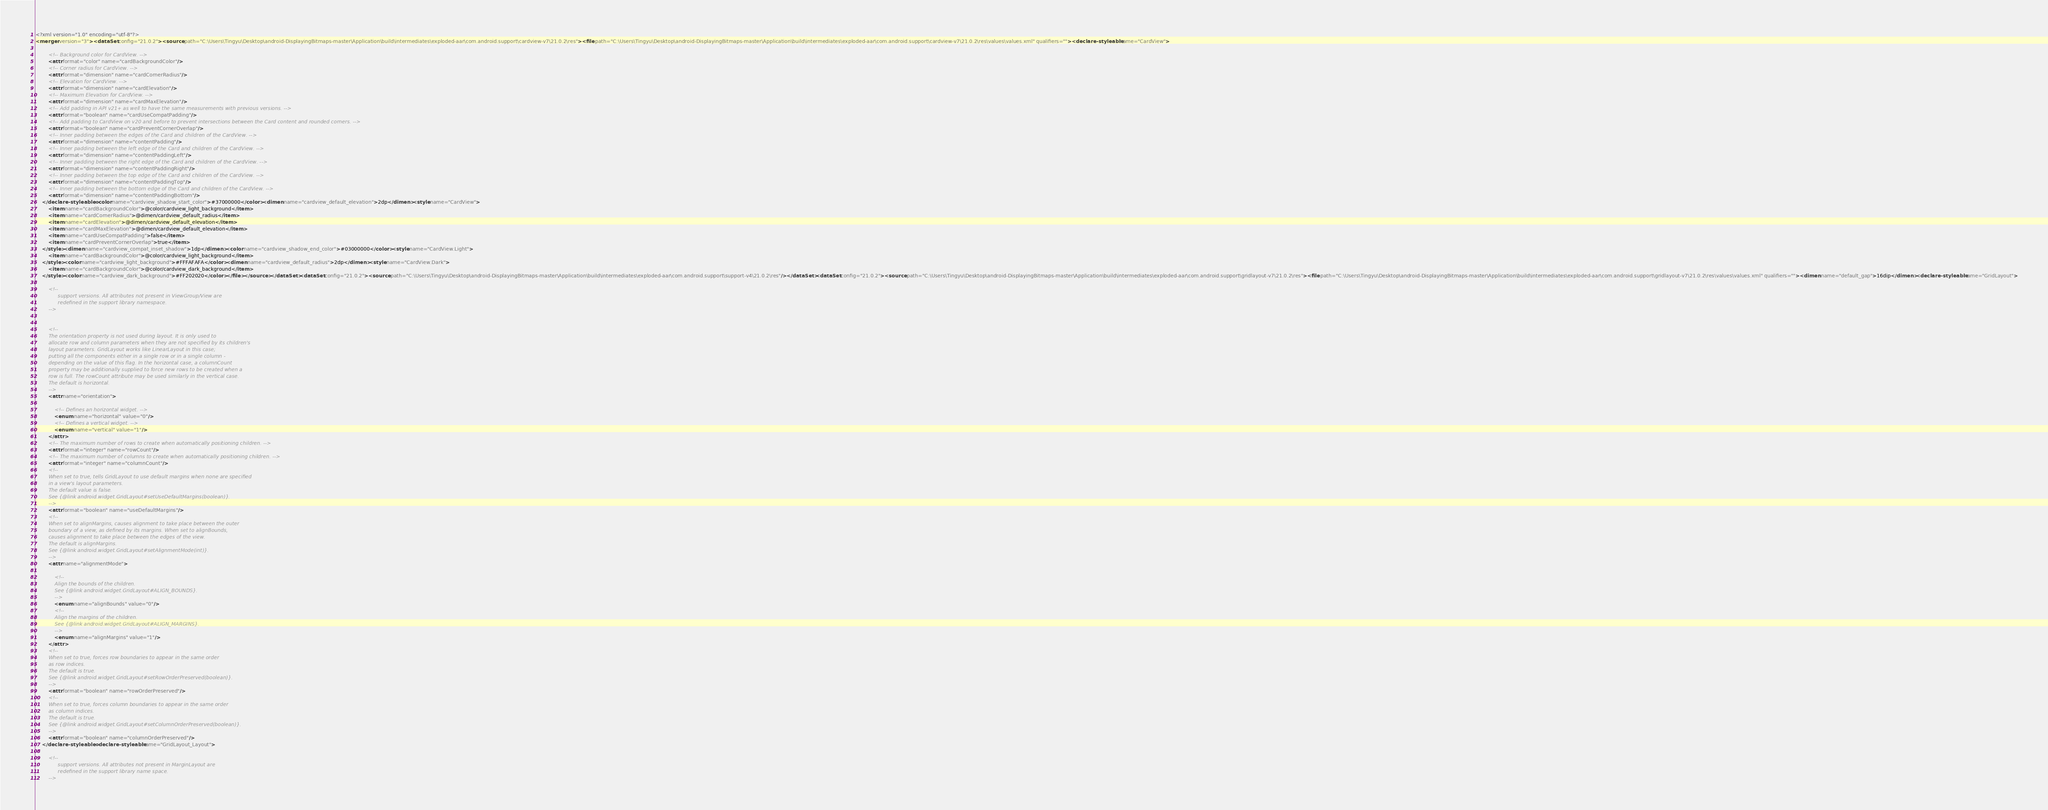<code> <loc_0><loc_0><loc_500><loc_500><_XML_><?xml version="1.0" encoding="utf-8"?>
<merger version="3"><dataSet config="21.0.2"><source path="C:\Users\Tingyu\Desktop\android-DisplayingBitmaps-master\Application\build\intermediates\exploded-aar\com.android.support\cardview-v7\21.0.2\res"><file path="C:\Users\Tingyu\Desktop\android-DisplayingBitmaps-master\Application\build\intermediates\exploded-aar\com.android.support\cardview-v7\21.0.2\res\values\values.xml" qualifiers=""><declare-styleable name="CardView">

        <!-- Background color for CardView. -->
        <attr format="color" name="cardBackgroundColor"/>
        <!-- Corner radius for CardView. -->
        <attr format="dimension" name="cardCornerRadius"/>
        <!-- Elevation for CardView. -->
        <attr format="dimension" name="cardElevation"/>
        <!-- Maximum Elevation for CardView. -->
        <attr format="dimension" name="cardMaxElevation"/>
        <!-- Add padding in API v21+ as well to have the same measurements with previous versions. -->
        <attr format="boolean" name="cardUseCompatPadding"/>
        <!-- Add padding to CardView on v20 and before to prevent intersections between the Card content and rounded corners. -->
        <attr format="boolean" name="cardPreventCornerOverlap"/>
        <!-- Inner padding between the edges of the Card and children of the CardView. -->
        <attr format="dimension" name="contentPadding"/>
        <!-- Inner padding between the left edge of the Card and children of the CardView. -->
        <attr format="dimension" name="contentPaddingLeft"/>
        <!-- Inner padding between the right edge of the Card and children of the CardView. -->
        <attr format="dimension" name="contentPaddingRight"/>
        <!-- Inner padding between the top edge of the Card and children of the CardView. -->
        <attr format="dimension" name="contentPaddingTop"/>
        <!-- Inner padding between the bottom edge of the Card and children of the CardView. -->
        <attr format="dimension" name="contentPaddingBottom"/>
    </declare-styleable><color name="cardview_shadow_start_color">#37000000</color><dimen name="cardview_default_elevation">2dp</dimen><style name="CardView">
        <item name="cardBackgroundColor">@color/cardview_light_background</item>
        <item name="cardCornerRadius">@dimen/cardview_default_radius</item>
        <item name="cardElevation">@dimen/cardview_default_elevation</item>
        <item name="cardMaxElevation">@dimen/cardview_default_elevation</item>
        <item name="cardUseCompatPadding">false</item>
        <item name="cardPreventCornerOverlap">true</item>
    </style><dimen name="cardview_compat_inset_shadow">1dp</dimen><color name="cardview_shadow_end_color">#03000000</color><style name="CardView.Light">
        <item name="cardBackgroundColor">@color/cardview_light_background</item>
    </style><color name="cardview_light_background">#FFFAFAFA</color><dimen name="cardview_default_radius">2dp</dimen><style name="CardView.Dark">
        <item name="cardBackgroundColor">@color/cardview_dark_background</item>
    </style><color name="cardview_dark_background">#FF202020</color></file></source></dataSet><dataSet config="21.0.2"><source path="C:\Users\Tingyu\Desktop\android-DisplayingBitmaps-master\Application\build\intermediates\exploded-aar\com.android.support\support-v4\21.0.2\res"/></dataSet><dataSet config="21.0.2"><source path="C:\Users\Tingyu\Desktop\android-DisplayingBitmaps-master\Application\build\intermediates\exploded-aar\com.android.support\gridlayout-v7\21.0.2\res"><file path="C:\Users\Tingyu\Desktop\android-DisplayingBitmaps-master\Application\build\intermediates\exploded-aar\com.android.support\gridlayout-v7\21.0.2\res\values\values.xml" qualifiers=""><dimen name="default_gap">16dip</dimen><declare-styleable name="GridLayout">

        <!--
              support versions. All attributes not present in ViewGroup/View are
              redefined in the support library namespace.
        -->


        <!--
        The orientation property is not used during layout. It is only used to
        allocate row and column parameters when they are not specified by its children's
        layout parameters. GridLayout works like LinearLayout in this case;
        putting all the components either in a single row or in a single column -
        depending on the value of this flag. In the horizontal case, a columnCount
        property may be additionally supplied to force new rows to be created when a
        row is full. The rowCount attribute may be used similarly in the vertical case.
        The default is horizontal.
        -->
        <attr name="orientation">

            <!-- Defines an horizontal widget. -->
            <enum name="horizontal" value="0"/>
            <!-- Defines a vertical widget. -->
            <enum name="vertical" value="1"/>
        </attr>
        <!-- The maximum number of rows to create when automatically positioning children. -->
        <attr format="integer" name="rowCount"/>
        <!-- The maximum number of columns to create when automatically positioning children. -->
        <attr format="integer" name="columnCount"/>
        <!--
        When set to true, tells GridLayout to use default margins when none are specified
        in a view's layout parameters.
        The default value is false.
        See {@link android.widget.GridLayout#setUseDefaultMargins(boolean)}.
        -->
        <attr format="boolean" name="useDefaultMargins"/>
        <!--
        When set to alignMargins, causes alignment to take place between the outer
        boundary of a view, as defined by its margins. When set to alignBounds,
        causes alignment to take place between the edges of the view.
        The default is alignMargins.
        See {@link android.widget.GridLayout#setAlignmentMode(int)}.
        -->
        <attr name="alignmentMode">

            <!--
            Align the bounds of the children.
            See {@link android.widget.GridLayout#ALIGN_BOUNDS}.
            -->
            <enum name="alignBounds" value="0"/>
            <!--
            Align the margins of the children.
            See {@link android.widget.GridLayout#ALIGN_MARGINS}.
            -->
            <enum name="alignMargins" value="1"/>
        </attr>
        <!--
        When set to true, forces row boundaries to appear in the same order
        as row indices.
        The default is true.
        See {@link android.widget.GridLayout#setRowOrderPreserved(boolean)}.
        -->
        <attr format="boolean" name="rowOrderPreserved"/>
        <!--
        When set to true, forces column boundaries to appear in the same order
        as column indices.
        The default is true.
        See {@link android.widget.GridLayout#setColumnOrderPreserved(boolean)}.
        -->
        <attr format="boolean" name="columnOrderPreserved"/>
    </declare-styleable><declare-styleable name="GridLayout_Layout">

        <!--
              support versions. All attributes not present in MarginLayout are
              redefined in the support library name space.
        -->

</code> 